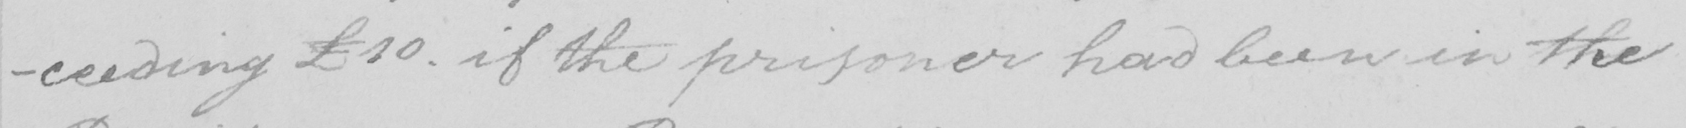What text is written in this handwritten line? -ceeding £10 . if the prisoner had been in the 